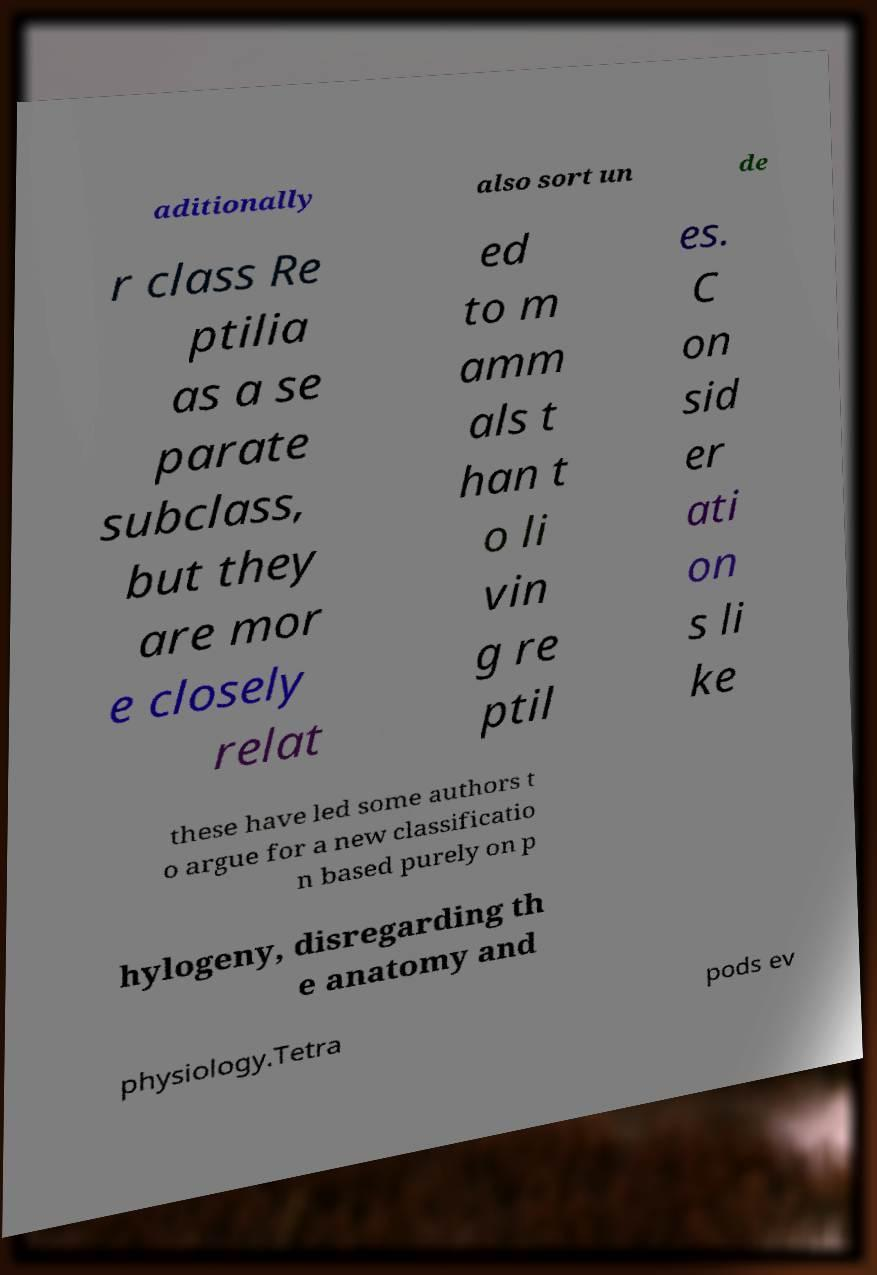What messages or text are displayed in this image? I need them in a readable, typed format. aditionally also sort un de r class Re ptilia as a se parate subclass, but they are mor e closely relat ed to m amm als t han t o li vin g re ptil es. C on sid er ati on s li ke these have led some authors t o argue for a new classificatio n based purely on p hylogeny, disregarding th e anatomy and physiology.Tetra pods ev 